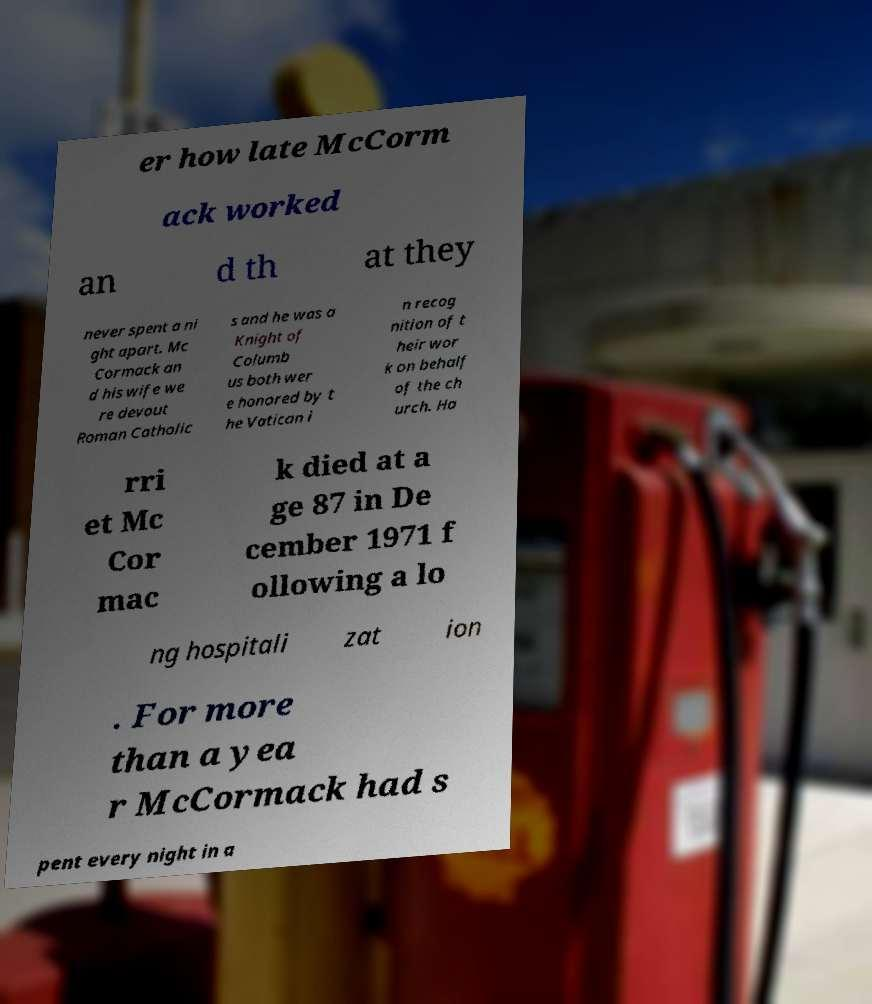Could you assist in decoding the text presented in this image and type it out clearly? er how late McCorm ack worked an d th at they never spent a ni ght apart. Mc Cormack an d his wife we re devout Roman Catholic s and he was a Knight of Columb us both wer e honored by t he Vatican i n recog nition of t heir wor k on behalf of the ch urch. Ha rri et Mc Cor mac k died at a ge 87 in De cember 1971 f ollowing a lo ng hospitali zat ion . For more than a yea r McCormack had s pent every night in a 